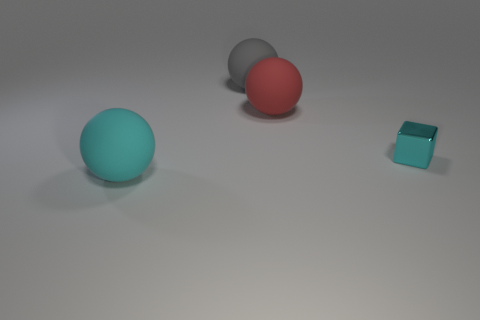Subtract all red matte spheres. How many spheres are left? 2 Add 1 red rubber objects. How many objects exist? 5 Subtract all gray balls. How many balls are left? 2 Add 1 small blue cylinders. How many small blue cylinders exist? 1 Subtract 1 cyan spheres. How many objects are left? 3 Subtract all cubes. How many objects are left? 3 Subtract 3 balls. How many balls are left? 0 Subtract all yellow blocks. Subtract all green spheres. How many blocks are left? 1 Subtract all green blocks. How many gray balls are left? 1 Subtract all tiny matte spheres. Subtract all cyan matte things. How many objects are left? 3 